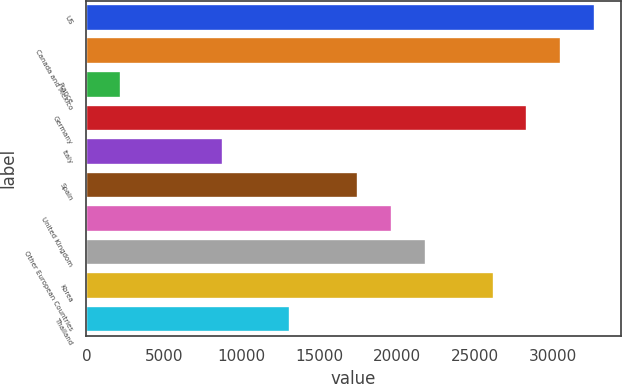Convert chart. <chart><loc_0><loc_0><loc_500><loc_500><bar_chart><fcel>US<fcel>Canada and Mexico<fcel>France<fcel>Germany<fcel>Italy<fcel>Spain<fcel>United Kingdom<fcel>Other European Countries<fcel>Korea<fcel>Thailand<nl><fcel>32751.5<fcel>30571.2<fcel>2227.3<fcel>28390.9<fcel>8768.2<fcel>17489.4<fcel>19669.7<fcel>21850<fcel>26210.6<fcel>13128.8<nl></chart> 